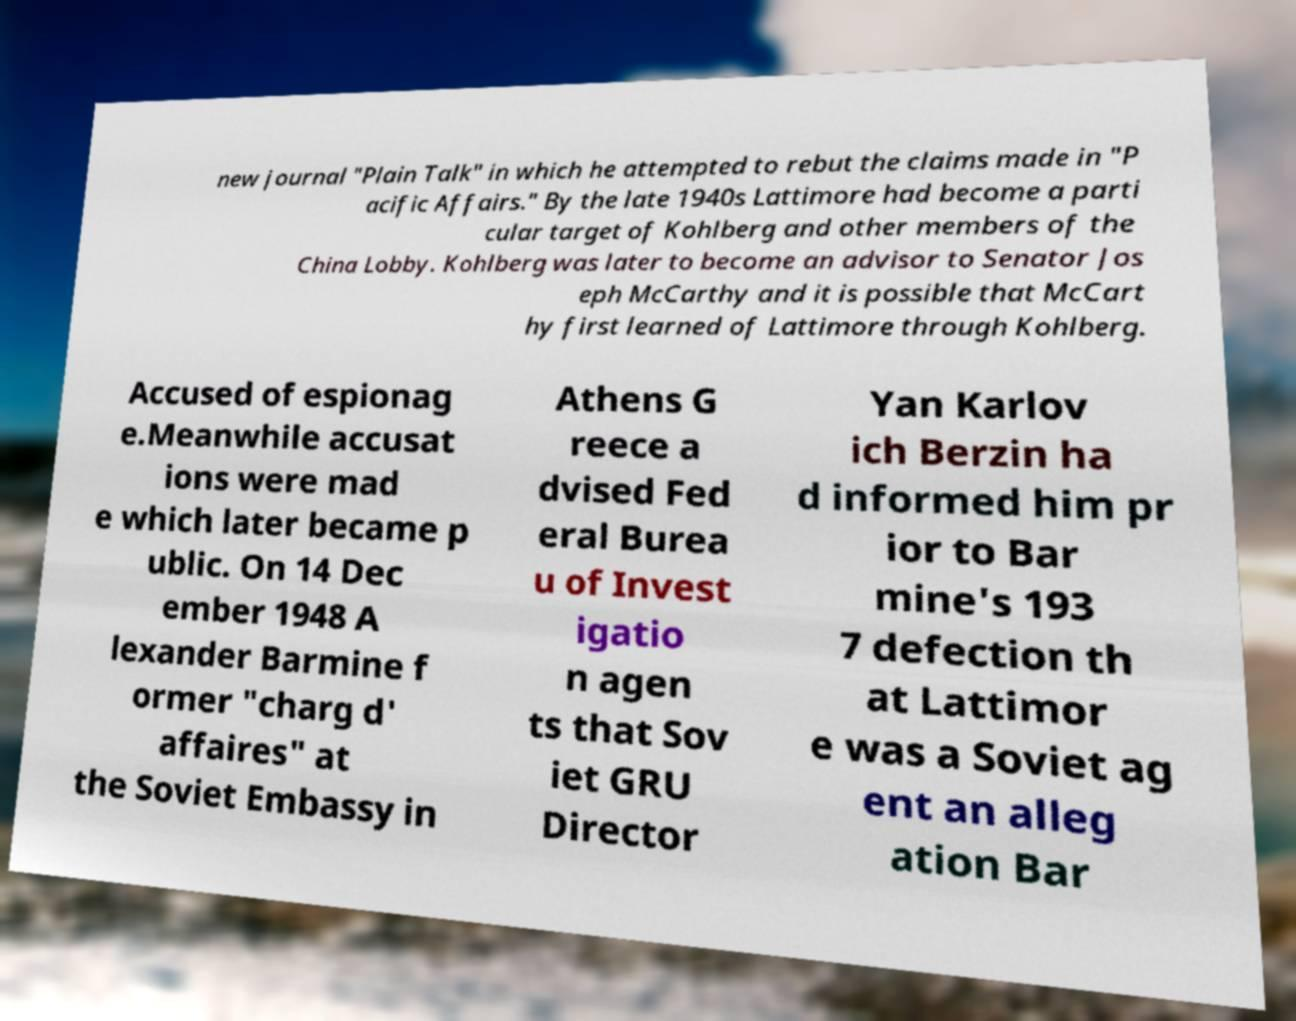Could you extract and type out the text from this image? new journal "Plain Talk" in which he attempted to rebut the claims made in "P acific Affairs." By the late 1940s Lattimore had become a parti cular target of Kohlberg and other members of the China Lobby. Kohlberg was later to become an advisor to Senator Jos eph McCarthy and it is possible that McCart hy first learned of Lattimore through Kohlberg. Accused of espionag e.Meanwhile accusat ions were mad e which later became p ublic. On 14 Dec ember 1948 A lexander Barmine f ormer "charg d' affaires" at the Soviet Embassy in Athens G reece a dvised Fed eral Burea u of Invest igatio n agen ts that Sov iet GRU Director Yan Karlov ich Berzin ha d informed him pr ior to Bar mine's 193 7 defection th at Lattimor e was a Soviet ag ent an alleg ation Bar 